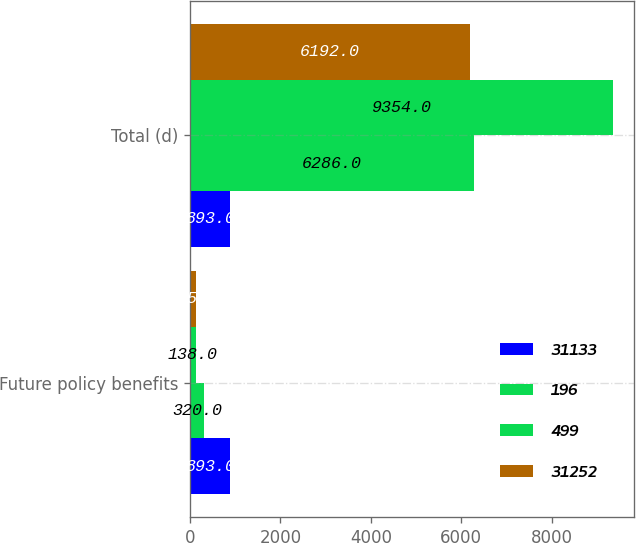Convert chart. <chart><loc_0><loc_0><loc_500><loc_500><stacked_bar_chart><ecel><fcel>Future policy benefits<fcel>Total (d)<nl><fcel>31133<fcel>893<fcel>893<nl><fcel>196<fcel>320<fcel>6286<nl><fcel>499<fcel>138<fcel>9354<nl><fcel>31252<fcel>135<fcel>6192<nl></chart> 